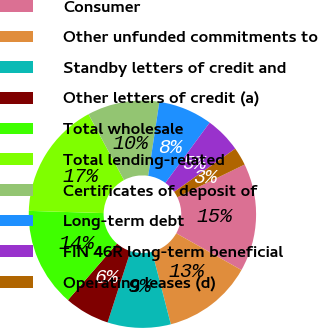Convert chart. <chart><loc_0><loc_0><loc_500><loc_500><pie_chart><fcel>Consumer<fcel>Other unfunded commitments to<fcel>Standby letters of credit and<fcel>Other letters of credit (a)<fcel>Total wholesale<fcel>Total lending-related<fcel>Certificates of deposit of<fcel>Long-term debt<fcel>FIN 46R long-term beneficial<fcel>Operating leases (d)<nl><fcel>15.38%<fcel>12.82%<fcel>8.98%<fcel>6.42%<fcel>14.1%<fcel>16.66%<fcel>10.26%<fcel>7.7%<fcel>5.14%<fcel>2.58%<nl></chart> 